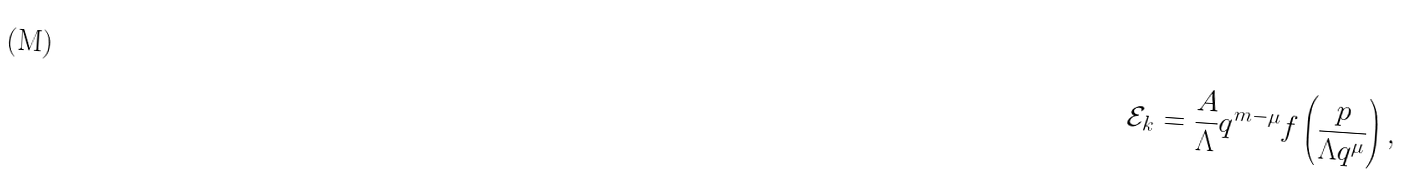<formula> <loc_0><loc_0><loc_500><loc_500>\mathcal { E } _ { k } = \frac { A } { \Lambda } q ^ { m - \mu } f \left ( \frac { p } { \Lambda q ^ { \mu } } \right ) ,</formula> 